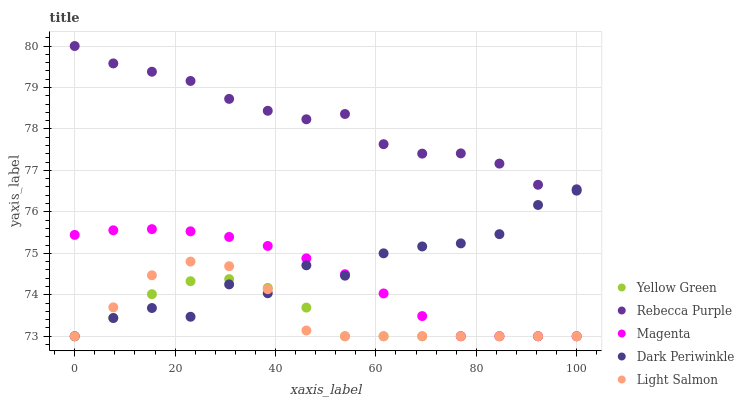Does Yellow Green have the minimum area under the curve?
Answer yes or no. Yes. Does Rebecca Purple have the maximum area under the curve?
Answer yes or no. Yes. Does Magenta have the minimum area under the curve?
Answer yes or no. No. Does Magenta have the maximum area under the curve?
Answer yes or no. No. Is Magenta the smoothest?
Answer yes or no. Yes. Is Dark Periwinkle the roughest?
Answer yes or no. Yes. Is Light Salmon the smoothest?
Answer yes or no. No. Is Light Salmon the roughest?
Answer yes or no. No. Does Dark Periwinkle have the lowest value?
Answer yes or no. Yes. Does Rebecca Purple have the lowest value?
Answer yes or no. No. Does Rebecca Purple have the highest value?
Answer yes or no. Yes. Does Magenta have the highest value?
Answer yes or no. No. Is Yellow Green less than Rebecca Purple?
Answer yes or no. Yes. Is Rebecca Purple greater than Dark Periwinkle?
Answer yes or no. Yes. Does Magenta intersect Yellow Green?
Answer yes or no. Yes. Is Magenta less than Yellow Green?
Answer yes or no. No. Is Magenta greater than Yellow Green?
Answer yes or no. No. Does Yellow Green intersect Rebecca Purple?
Answer yes or no. No. 